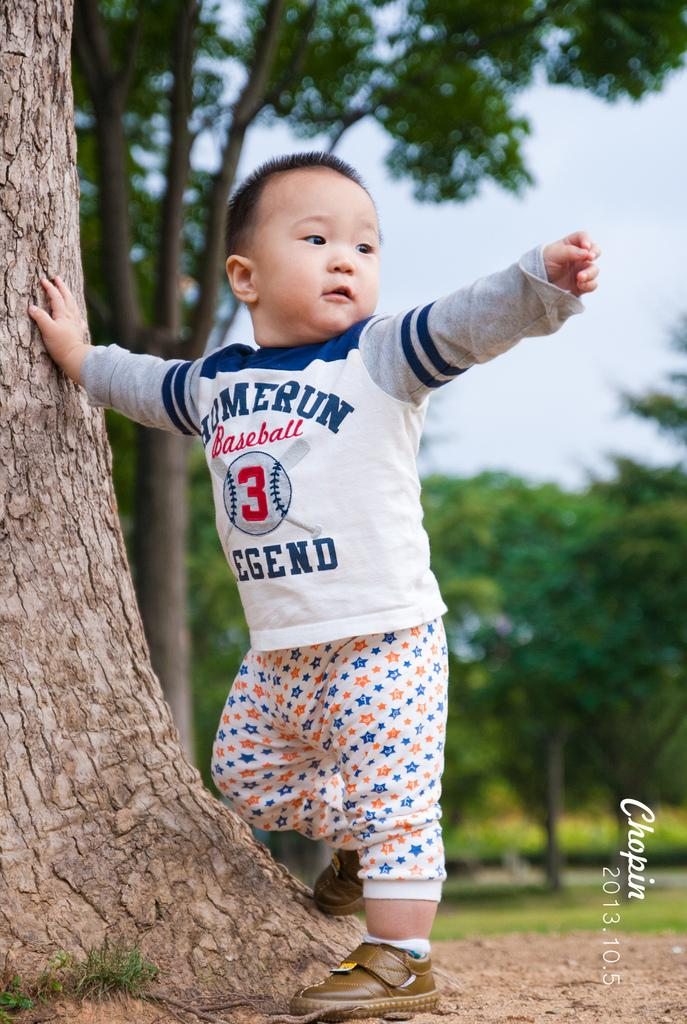What is the main subject of the image? There is a child in the image. What is the child doing in the image? The child is standing on the ground and touching the trunk of a tree. What can be seen in the background of the image? There is sky and trees visible in the background of the image. Can you see the child creating a wave in the image? There is no wave present in the image, and the child is not creating one. Is the child slipping on the ground in the image? The child is standing on the ground, and there is no indication that they are slipping. 